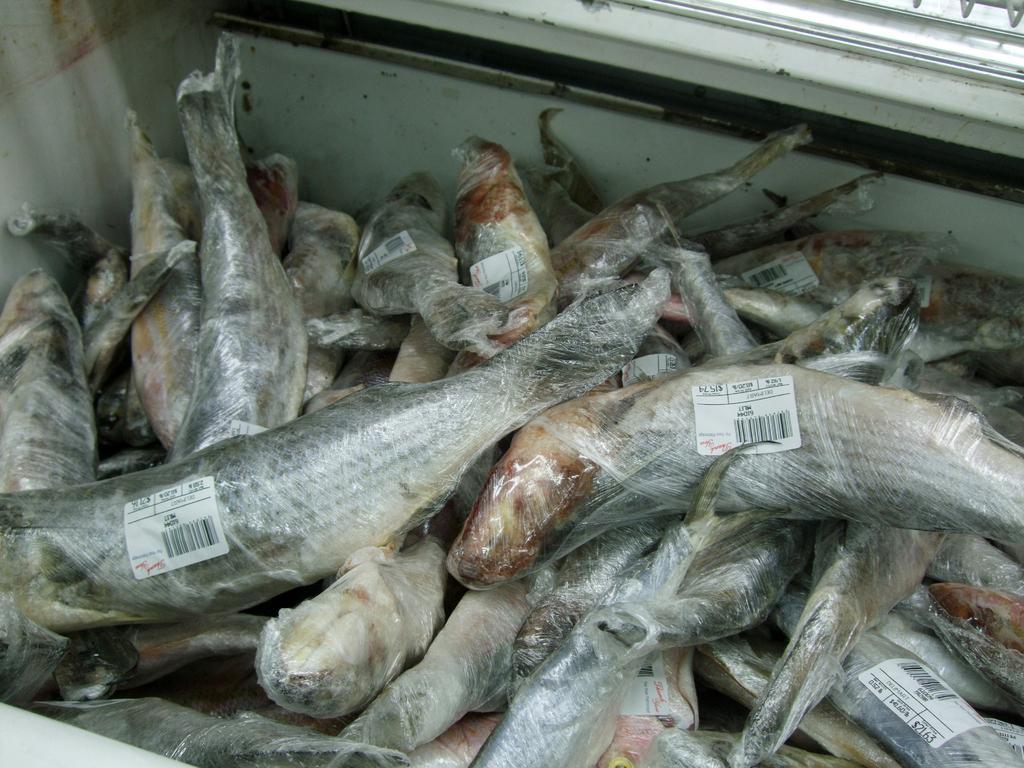Can you describe this image briefly? In this image we can see a group of fishes and there are covered with plastic covers. On the covers we can see the labels with text and barcodes. All the fishes are placed in a box. 